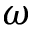<formula> <loc_0><loc_0><loc_500><loc_500>\omega</formula> 